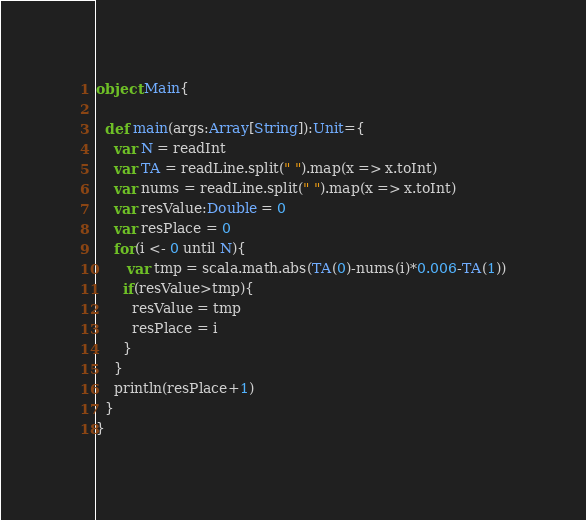Convert code to text. <code><loc_0><loc_0><loc_500><loc_500><_Scala_>object Main{
  
  def main(args:Array[String]):Unit={
    var N = readInt
    var TA = readLine.split(" ").map(x => x.toInt)
    var nums = readLine.split(" ").map(x => x.toInt)
    var resValue:Double = 0
    var resPlace = 0
    for(i <- 0 until N){
       var tmp = scala.math.abs(TA(0)-nums(i)*0.006-TA(1))
      if(resValue>tmp){
        resValue = tmp
        resPlace = i
      }
    }
    println(resPlace+1)
  }
}</code> 